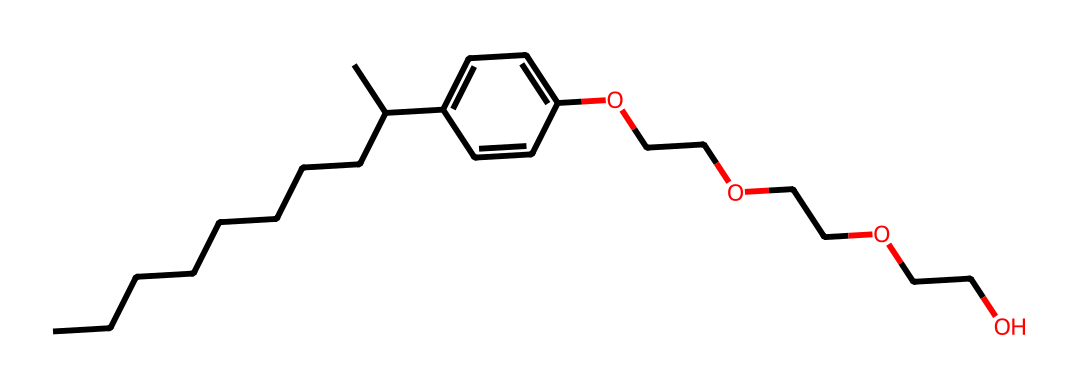What is the molecular formula of nonylphenol ethoxylates? To determine the molecular formula, we analyze the SMILES representation, counting the carbon (C), hydrogen (H), and oxygen (O) atoms. There are 17 carbon atoms, 30 hydrogen atoms, and 3 oxygen atoms in the chemical structure.
Answer: C17H30O3 How many oxygen atoms are present in this compound? From the SMILES representation, we identify that there are three "O" symbols indicating three oxygen atoms in the structure of nonylphenol ethoxylates.
Answer: 3 What type of functional group is observed in nonylphenol ethoxylates? Upon examining the SMILES structure, we see the presence of an alcohol group (-OH) as evidenced by the "OCC" part of the structure, which is characteristic of surfactants.
Answer: alcohol What is the role of nonylphenol ethoxylates in cleaning agents? Nonylphenol ethoxylates function as surfactants in cleaning agents, which allows them to reduce surface tension and improve wetting properties essential for cleaning.
Answer: surfactants How many ethylene oxide units are present in this molecule? The three "OCC" segments within the SMILES indicate that there are three units of ethylene oxide incorporated into the nonylphenol ethoxylate structure. Each "OCC" represents one ethylene oxide unit.
Answer: 3 